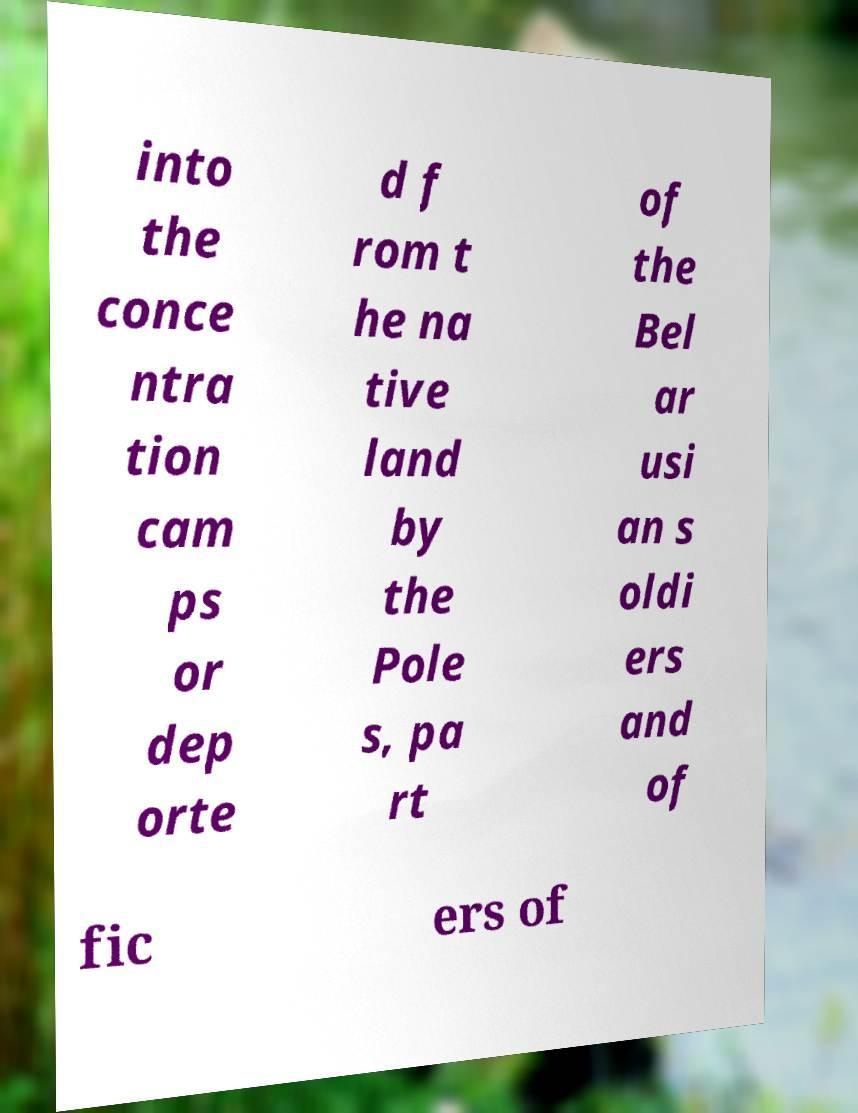Please read and relay the text visible in this image. What does it say? into the conce ntra tion cam ps or dep orte d f rom t he na tive land by the Pole s, pa rt of the Bel ar usi an s oldi ers and of fic ers of 